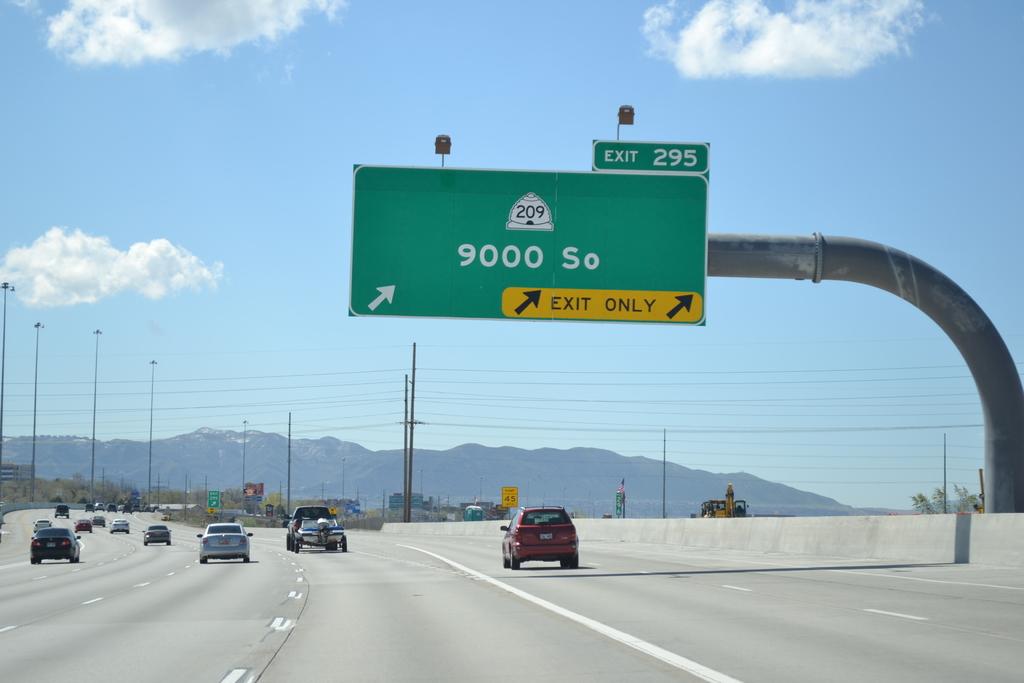Is this route 209?
Your answer should be very brief. Yes. 